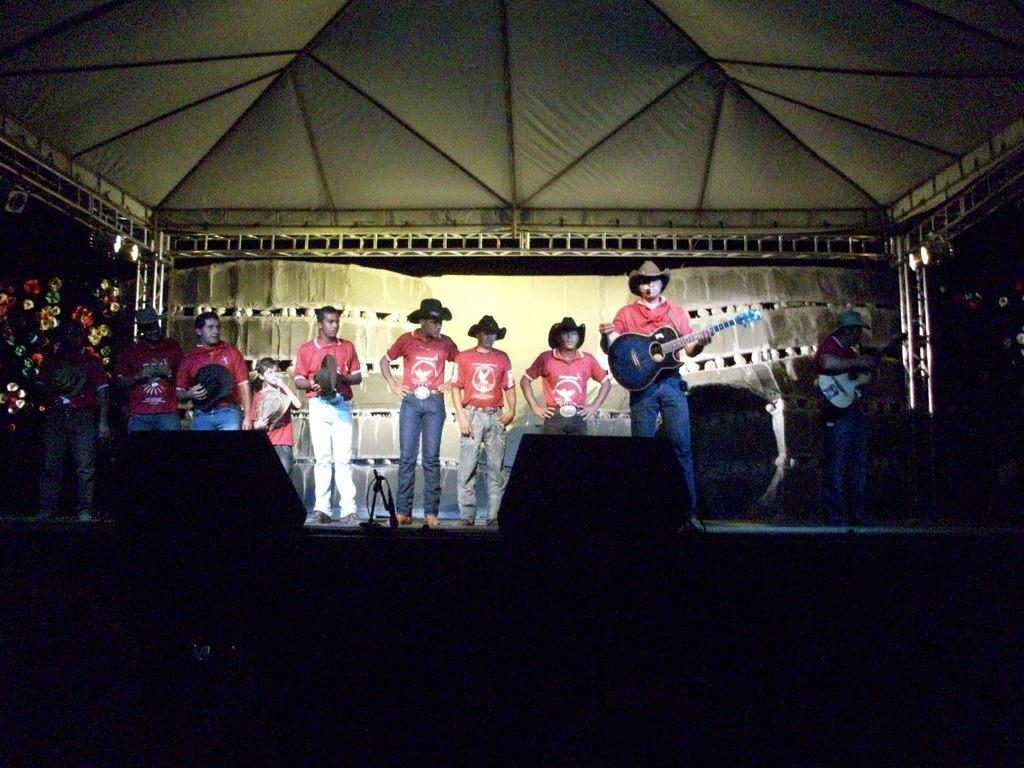What are the people in the image doing? There is a group of people standing on a stage, and two people are playing guitar. What can be seen above the stage? There is a roof above the stage. What is the temperature of the air on the stage in the image? The provided facts do not mention the temperature, so it cannot be determined from the image. What trick is being performed by the guitar players in the image? There is no indication of a trick being performed by the guitar players in the image; they are simply playing their instruments. 